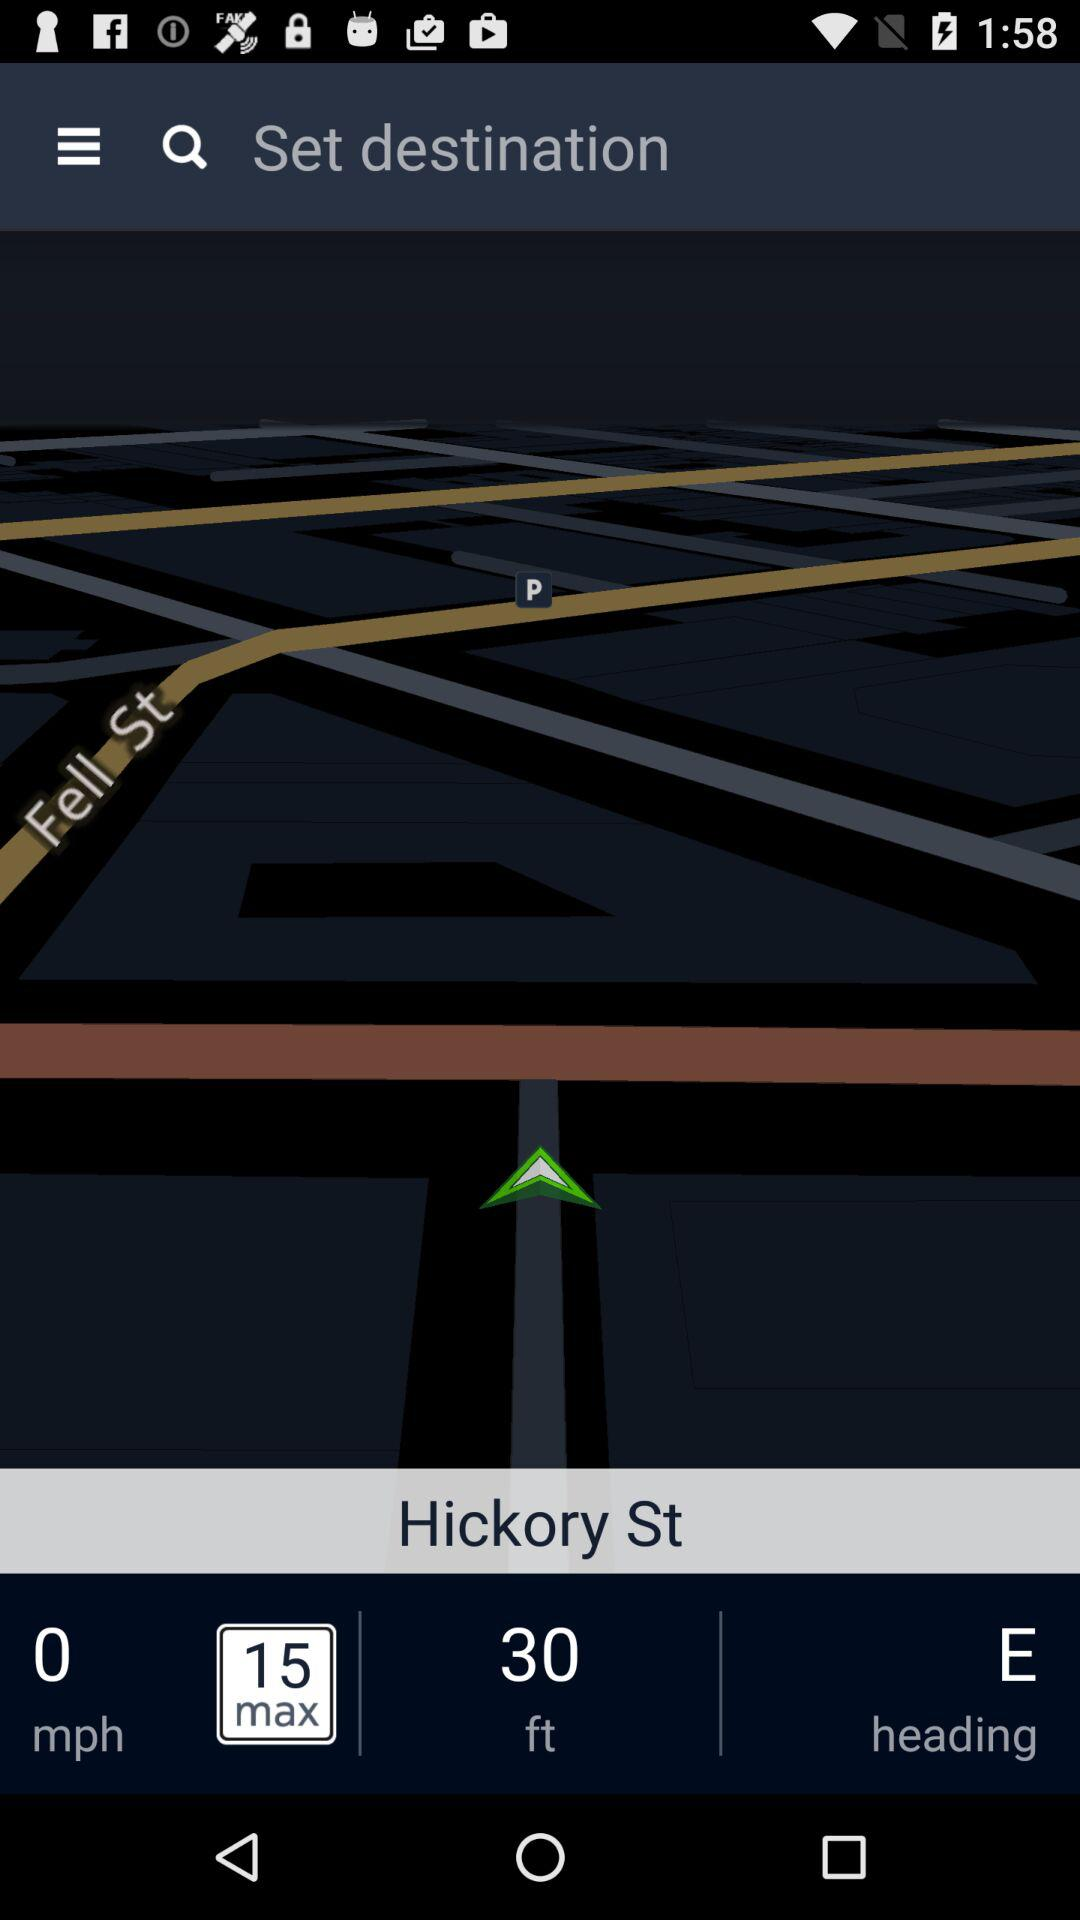How much more is the speed limit than the current speed?
Answer the question using a single word or phrase. 15 